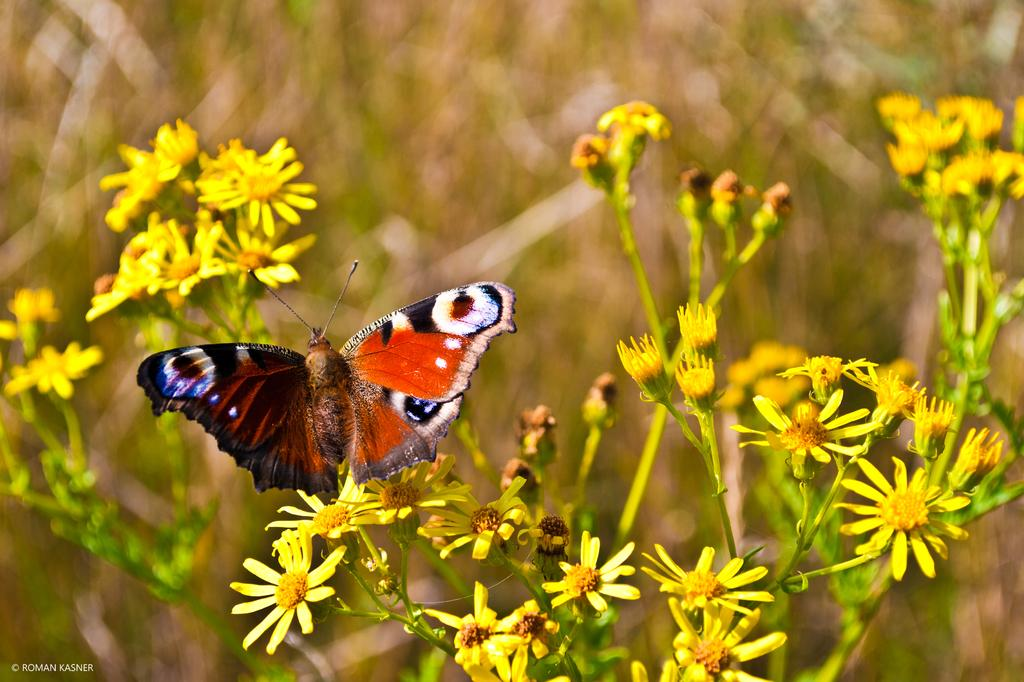What is located in the foreground of the image? There is a butterfly and flowers in the foreground of the image. What is the state of the plant in the foreground? The plant in the foreground has buds on it. How would you describe the background of the image? The background of the image is blurred. What type of thread is being used to hold up the mask in the image? There is no mask or thread present in the image. 